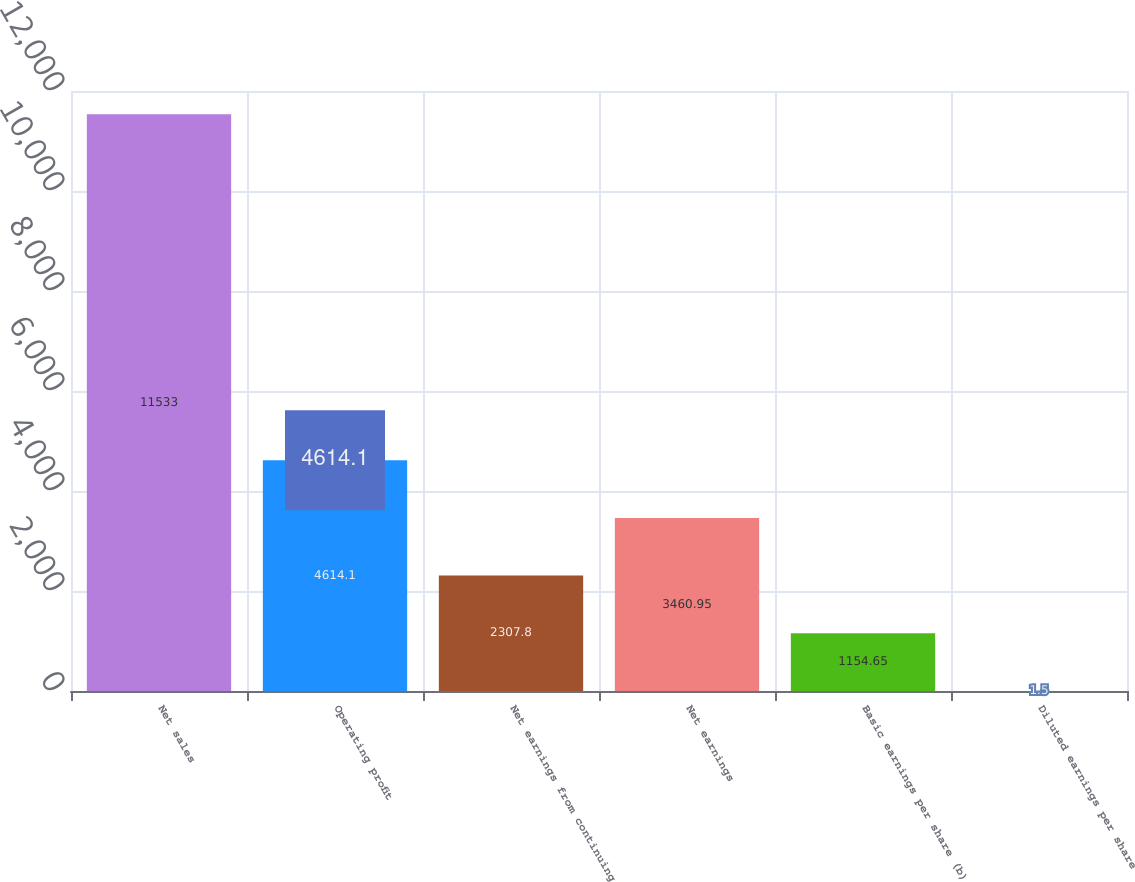Convert chart to OTSL. <chart><loc_0><loc_0><loc_500><loc_500><bar_chart><fcel>Net sales<fcel>Operating profit<fcel>Net earnings from continuing<fcel>Net earnings<fcel>Basic earnings per share (b)<fcel>Diluted earnings per share<nl><fcel>11533<fcel>4614.1<fcel>2307.8<fcel>3460.95<fcel>1154.65<fcel>1.5<nl></chart> 